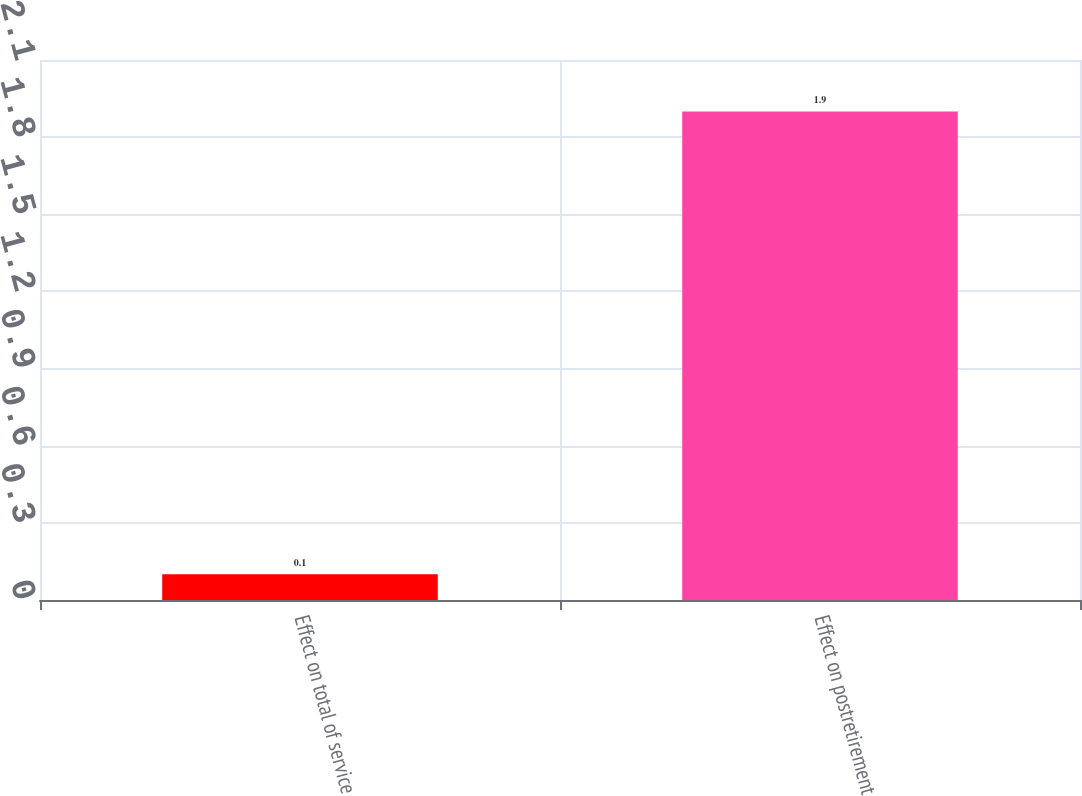<chart> <loc_0><loc_0><loc_500><loc_500><bar_chart><fcel>Effect on total of service<fcel>Effect on postretirement<nl><fcel>0.1<fcel>1.9<nl></chart> 